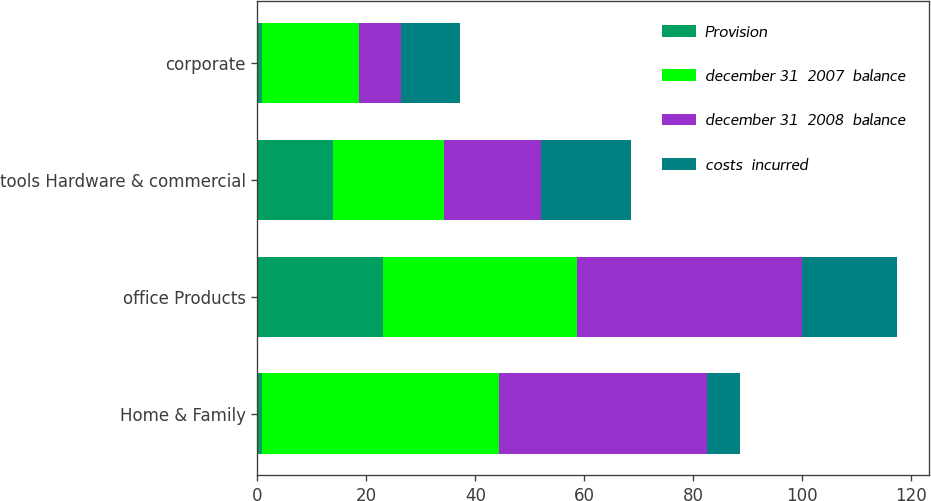<chart> <loc_0><loc_0><loc_500><loc_500><stacked_bar_chart><ecel><fcel>Home & Family<fcel>office Products<fcel>tools Hardware & commercial<fcel>corporate<nl><fcel>Provision<fcel>0.8<fcel>23.1<fcel>13.9<fcel>0.9<nl><fcel>december 31  2007  balance<fcel>43.5<fcel>35.6<fcel>20.4<fcel>17.7<nl><fcel>december 31  2008  balance<fcel>38.2<fcel>41.2<fcel>17.8<fcel>7.7<nl><fcel>costs  incurred<fcel>6.1<fcel>17.5<fcel>16.5<fcel>10.9<nl></chart> 